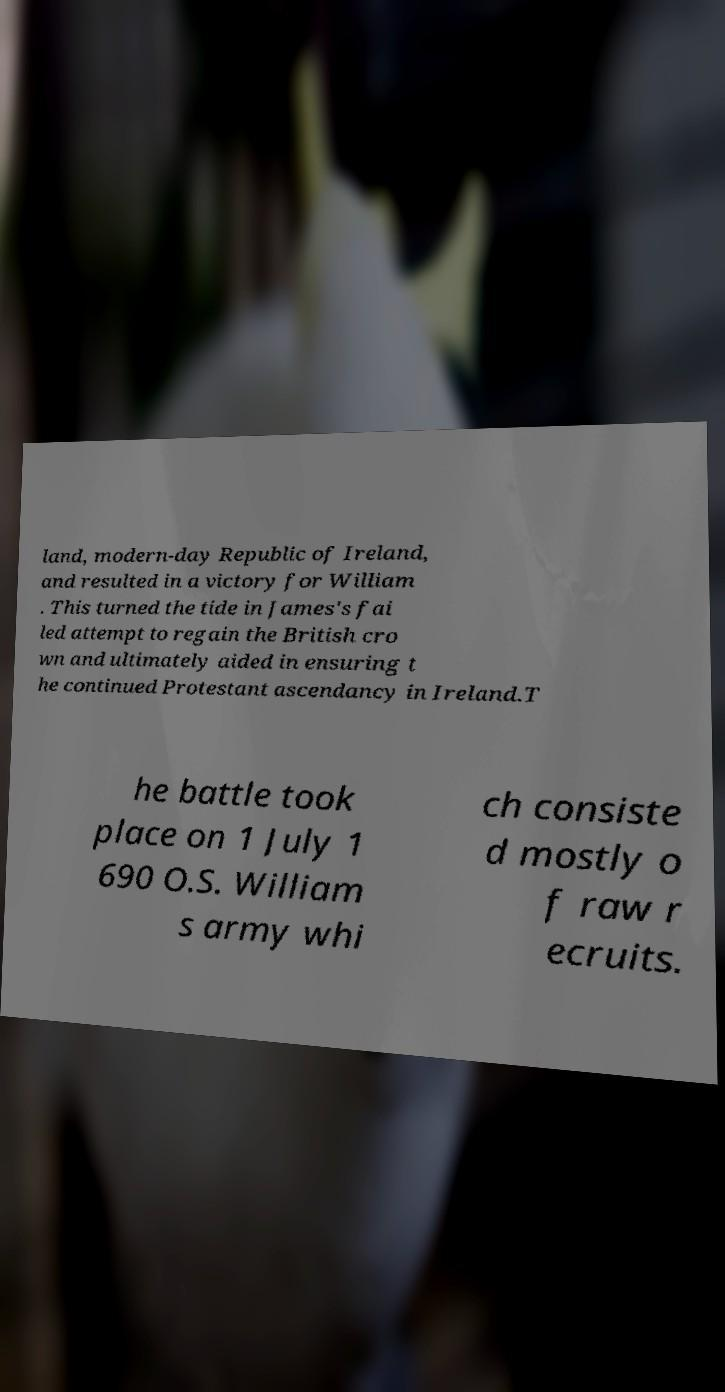Can you read and provide the text displayed in the image?This photo seems to have some interesting text. Can you extract and type it out for me? land, modern-day Republic of Ireland, and resulted in a victory for William . This turned the tide in James's fai led attempt to regain the British cro wn and ultimately aided in ensuring t he continued Protestant ascendancy in Ireland.T he battle took place on 1 July 1 690 O.S. William s army whi ch consiste d mostly o f raw r ecruits. 